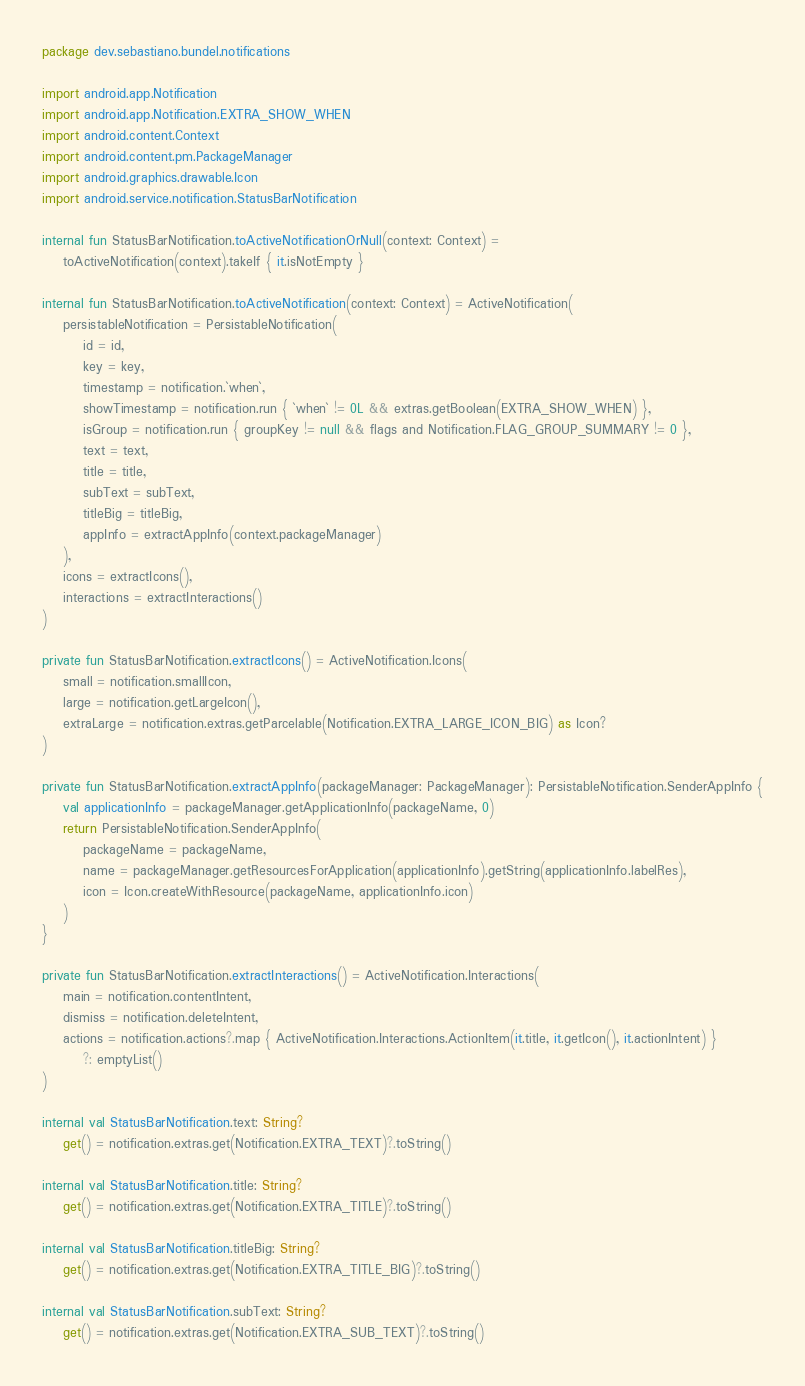<code> <loc_0><loc_0><loc_500><loc_500><_Kotlin_>package dev.sebastiano.bundel.notifications

import android.app.Notification
import android.app.Notification.EXTRA_SHOW_WHEN
import android.content.Context
import android.content.pm.PackageManager
import android.graphics.drawable.Icon
import android.service.notification.StatusBarNotification

internal fun StatusBarNotification.toActiveNotificationOrNull(context: Context) =
    toActiveNotification(context).takeIf { it.isNotEmpty }

internal fun StatusBarNotification.toActiveNotification(context: Context) = ActiveNotification(
    persistableNotification = PersistableNotification(
        id = id,
        key = key,
        timestamp = notification.`when`,
        showTimestamp = notification.run { `when` != 0L && extras.getBoolean(EXTRA_SHOW_WHEN) },
        isGroup = notification.run { groupKey != null && flags and Notification.FLAG_GROUP_SUMMARY != 0 },
        text = text,
        title = title,
        subText = subText,
        titleBig = titleBig,
        appInfo = extractAppInfo(context.packageManager)
    ),
    icons = extractIcons(),
    interactions = extractInteractions()
)

private fun StatusBarNotification.extractIcons() = ActiveNotification.Icons(
    small = notification.smallIcon,
    large = notification.getLargeIcon(),
    extraLarge = notification.extras.getParcelable(Notification.EXTRA_LARGE_ICON_BIG) as Icon?
)

private fun StatusBarNotification.extractAppInfo(packageManager: PackageManager): PersistableNotification.SenderAppInfo {
    val applicationInfo = packageManager.getApplicationInfo(packageName, 0)
    return PersistableNotification.SenderAppInfo(
        packageName = packageName,
        name = packageManager.getResourcesForApplication(applicationInfo).getString(applicationInfo.labelRes),
        icon = Icon.createWithResource(packageName, applicationInfo.icon)
    )
}

private fun StatusBarNotification.extractInteractions() = ActiveNotification.Interactions(
    main = notification.contentIntent,
    dismiss = notification.deleteIntent,
    actions = notification.actions?.map { ActiveNotification.Interactions.ActionItem(it.title, it.getIcon(), it.actionIntent) }
        ?: emptyList()
)

internal val StatusBarNotification.text: String?
    get() = notification.extras.get(Notification.EXTRA_TEXT)?.toString()

internal val StatusBarNotification.title: String?
    get() = notification.extras.get(Notification.EXTRA_TITLE)?.toString()

internal val StatusBarNotification.titleBig: String?
    get() = notification.extras.get(Notification.EXTRA_TITLE_BIG)?.toString()

internal val StatusBarNotification.subText: String?
    get() = notification.extras.get(Notification.EXTRA_SUB_TEXT)?.toString()
</code> 